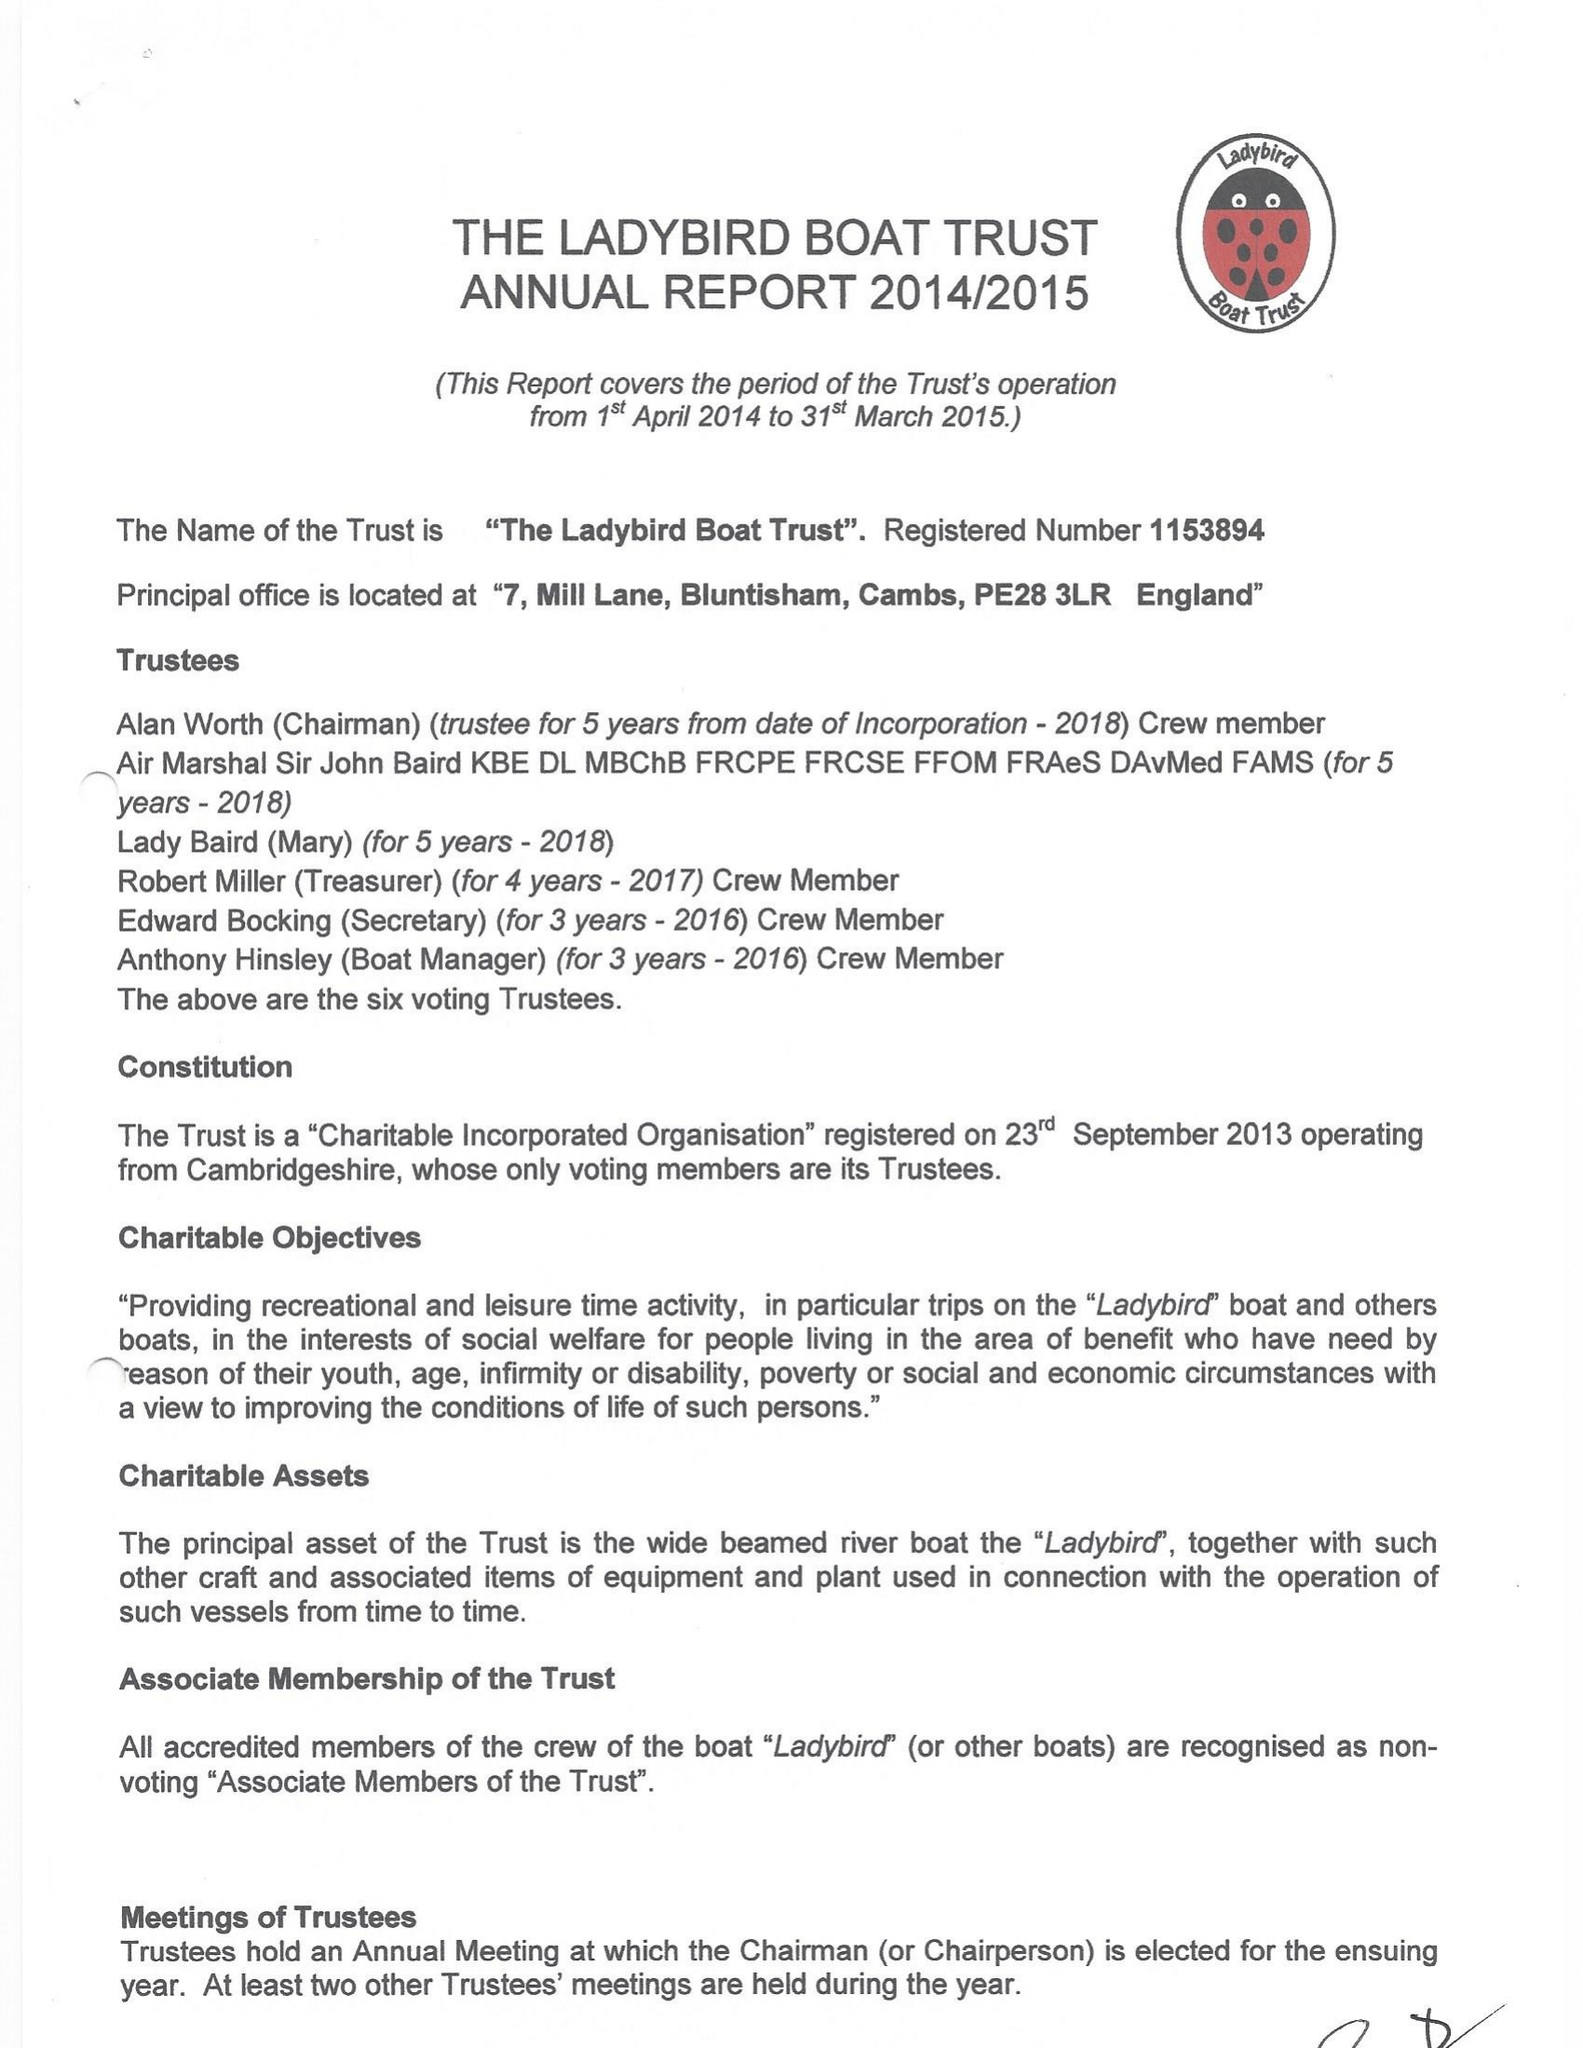What is the value for the address__street_line?
Answer the question using a single word or phrase. 13 HARTFORD ROAD 